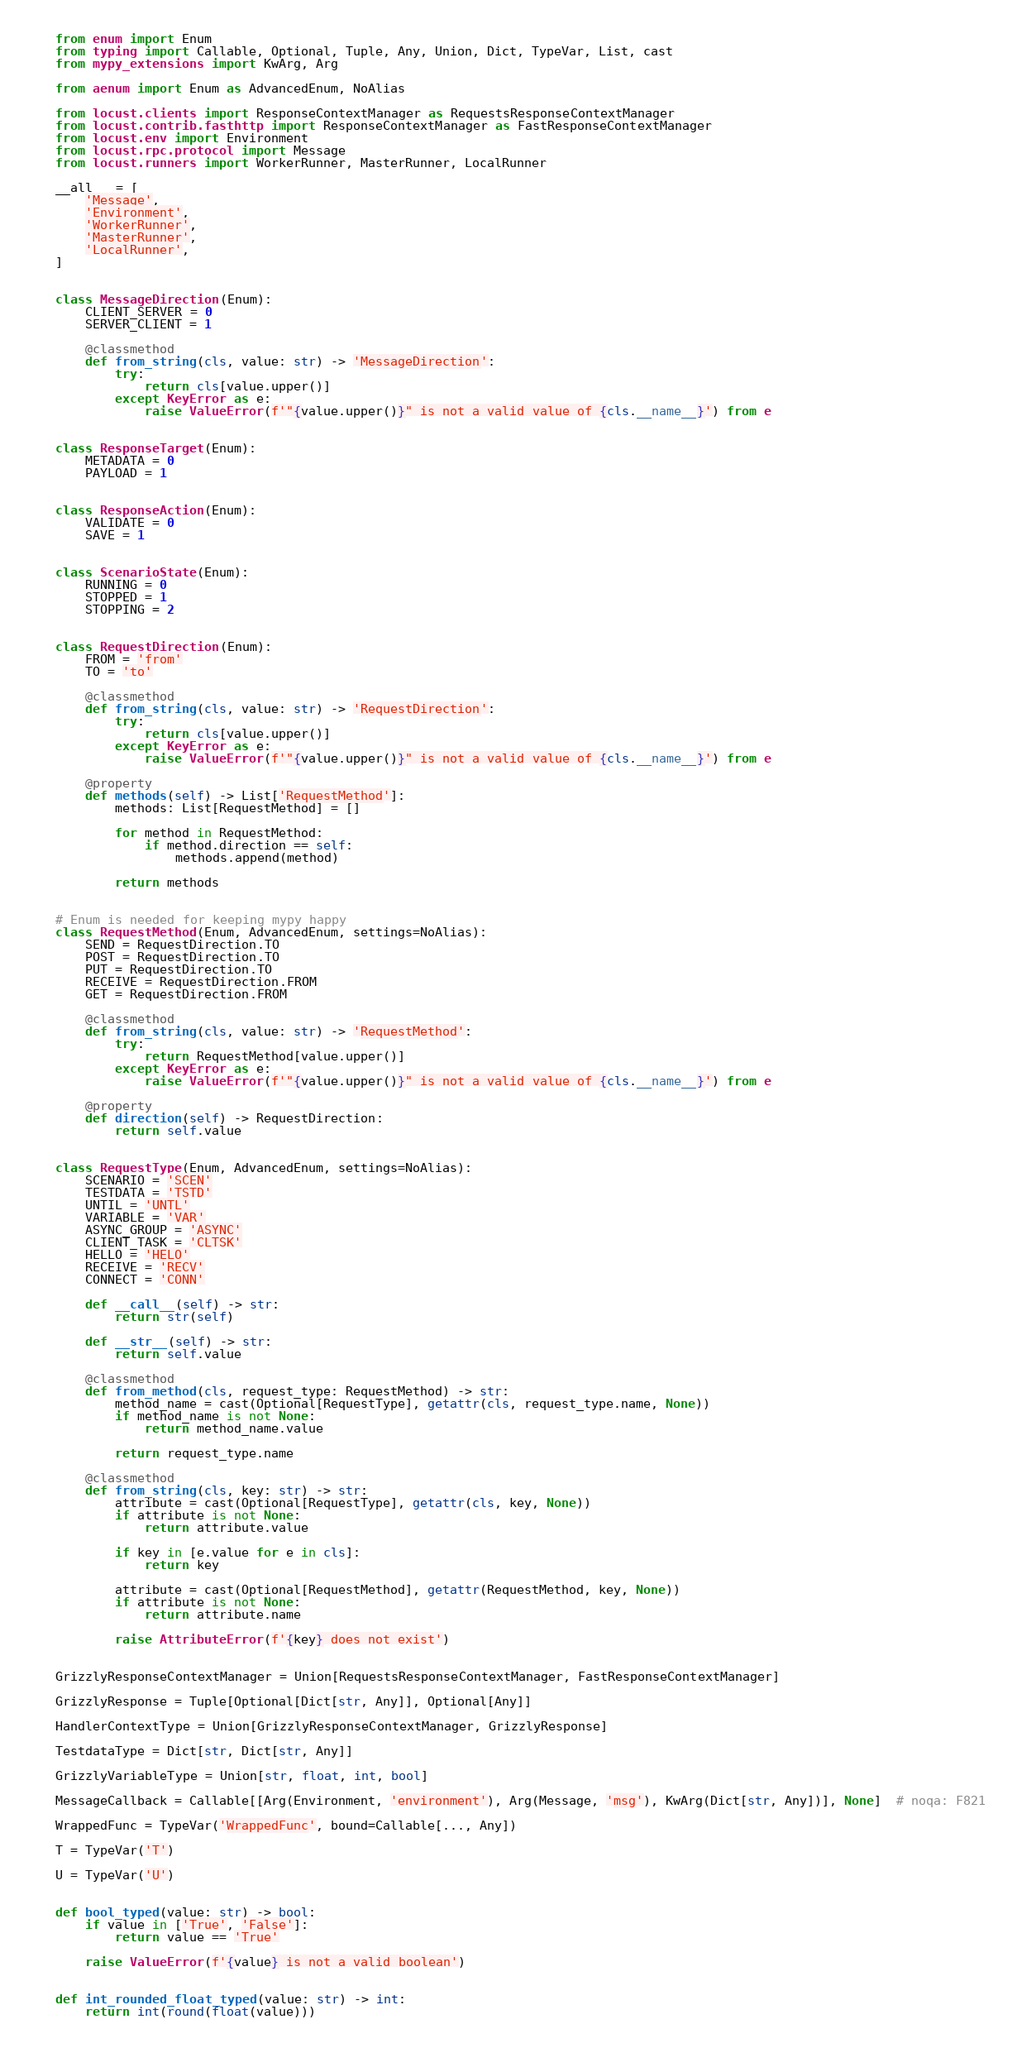Convert code to text. <code><loc_0><loc_0><loc_500><loc_500><_Python_>from enum import Enum
from typing import Callable, Optional, Tuple, Any, Union, Dict, TypeVar, List, cast
from mypy_extensions import KwArg, Arg

from aenum import Enum as AdvancedEnum, NoAlias

from locust.clients import ResponseContextManager as RequestsResponseContextManager
from locust.contrib.fasthttp import ResponseContextManager as FastResponseContextManager
from locust.env import Environment
from locust.rpc.protocol import Message
from locust.runners import WorkerRunner, MasterRunner, LocalRunner

__all__ = [
    'Message',
    'Environment',
    'WorkerRunner',
    'MasterRunner',
    'LocalRunner',
]


class MessageDirection(Enum):
    CLIENT_SERVER = 0
    SERVER_CLIENT = 1

    @classmethod
    def from_string(cls, value: str) -> 'MessageDirection':
        try:
            return cls[value.upper()]
        except KeyError as e:
            raise ValueError(f'"{value.upper()}" is not a valid value of {cls.__name__}') from e


class ResponseTarget(Enum):
    METADATA = 0
    PAYLOAD = 1


class ResponseAction(Enum):
    VALIDATE = 0
    SAVE = 1


class ScenarioState(Enum):
    RUNNING = 0
    STOPPED = 1
    STOPPING = 2


class RequestDirection(Enum):
    FROM = 'from'
    TO = 'to'

    @classmethod
    def from_string(cls, value: str) -> 'RequestDirection':
        try:
            return cls[value.upper()]
        except KeyError as e:
            raise ValueError(f'"{value.upper()}" is not a valid value of {cls.__name__}') from e

    @property
    def methods(self) -> List['RequestMethod']:
        methods: List[RequestMethod] = []

        for method in RequestMethod:
            if method.direction == self:
                methods.append(method)

        return methods


# Enum is needed for keeping mypy happy
class RequestMethod(Enum, AdvancedEnum, settings=NoAlias):
    SEND = RequestDirection.TO
    POST = RequestDirection.TO
    PUT = RequestDirection.TO
    RECEIVE = RequestDirection.FROM
    GET = RequestDirection.FROM

    @classmethod
    def from_string(cls, value: str) -> 'RequestMethod':
        try:
            return RequestMethod[value.upper()]
        except KeyError as e:
            raise ValueError(f'"{value.upper()}" is not a valid value of {cls.__name__}') from e

    @property
    def direction(self) -> RequestDirection:
        return self.value


class RequestType(Enum, AdvancedEnum, settings=NoAlias):
    SCENARIO = 'SCEN'
    TESTDATA = 'TSTD'
    UNTIL = 'UNTL'
    VARIABLE = 'VAR'
    ASYNC_GROUP = 'ASYNC'
    CLIENT_TASK = 'CLTSK'
    HELLO = 'HELO'
    RECEIVE = 'RECV'
    CONNECT = 'CONN'

    def __call__(self) -> str:
        return str(self)

    def __str__(self) -> str:
        return self.value

    @classmethod
    def from_method(cls, request_type: RequestMethod) -> str:
        method_name = cast(Optional[RequestType], getattr(cls, request_type.name, None))
        if method_name is not None:
            return method_name.value

        return request_type.name

    @classmethod
    def from_string(cls, key: str) -> str:
        attribute = cast(Optional[RequestType], getattr(cls, key, None))
        if attribute is not None:
            return attribute.value

        if key in [e.value for e in cls]:
            return key

        attribute = cast(Optional[RequestMethod], getattr(RequestMethod, key, None))
        if attribute is not None:
            return attribute.name

        raise AttributeError(f'{key} does not exist')


GrizzlyResponseContextManager = Union[RequestsResponseContextManager, FastResponseContextManager]

GrizzlyResponse = Tuple[Optional[Dict[str, Any]], Optional[Any]]

HandlerContextType = Union[GrizzlyResponseContextManager, GrizzlyResponse]

TestdataType = Dict[str, Dict[str, Any]]

GrizzlyVariableType = Union[str, float, int, bool]

MessageCallback = Callable[[Arg(Environment, 'environment'), Arg(Message, 'msg'), KwArg(Dict[str, Any])], None]  # noqa: F821

WrappedFunc = TypeVar('WrappedFunc', bound=Callable[..., Any])

T = TypeVar('T')

U = TypeVar('U')


def bool_typed(value: str) -> bool:
    if value in ['True', 'False']:
        return value == 'True'

    raise ValueError(f'{value} is not a valid boolean')


def int_rounded_float_typed(value: str) -> int:
    return int(round(float(value)))
</code> 